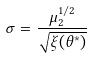<formula> <loc_0><loc_0><loc_500><loc_500>\sigma = \frac { \mu _ { 2 } ^ { 1 / 2 } } { \sqrt { \xi ( \theta ^ { * } ) } }</formula> 